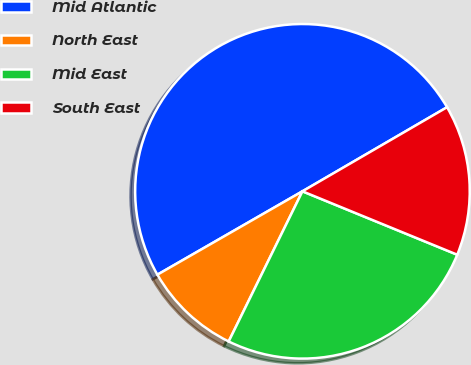Convert chart. <chart><loc_0><loc_0><loc_500><loc_500><pie_chart><fcel>Mid Atlantic<fcel>North East<fcel>Mid East<fcel>South East<nl><fcel>49.92%<fcel>9.43%<fcel>26.08%<fcel>14.57%<nl></chart> 